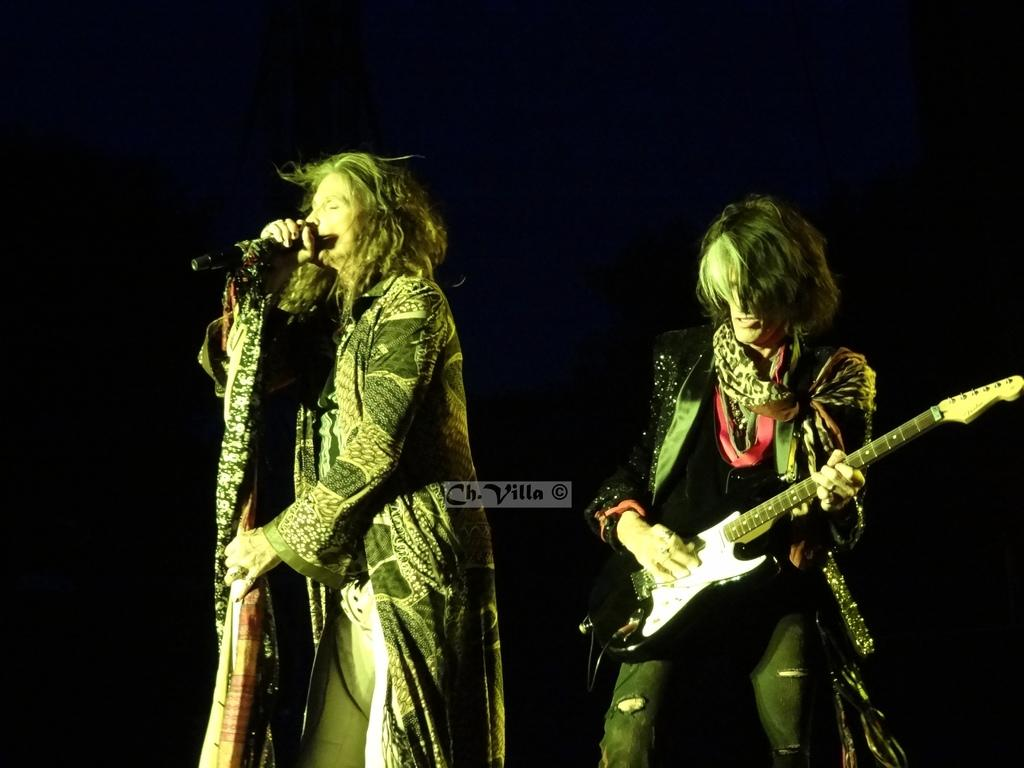What is the man in the image doing? The man is holding and playing a guitar in the image. What is the woman in the image doing? The woman is holding a microphone and singing in the image. What can be inferred about the setting based on the background color? The background of the image is in a dark color, which might suggest a dimly lit or indoor setting. What type of trains can be seen in the background of the image? There are no trains visible in the image; the background color is dark, but no specific objects or structures are mentioned. 